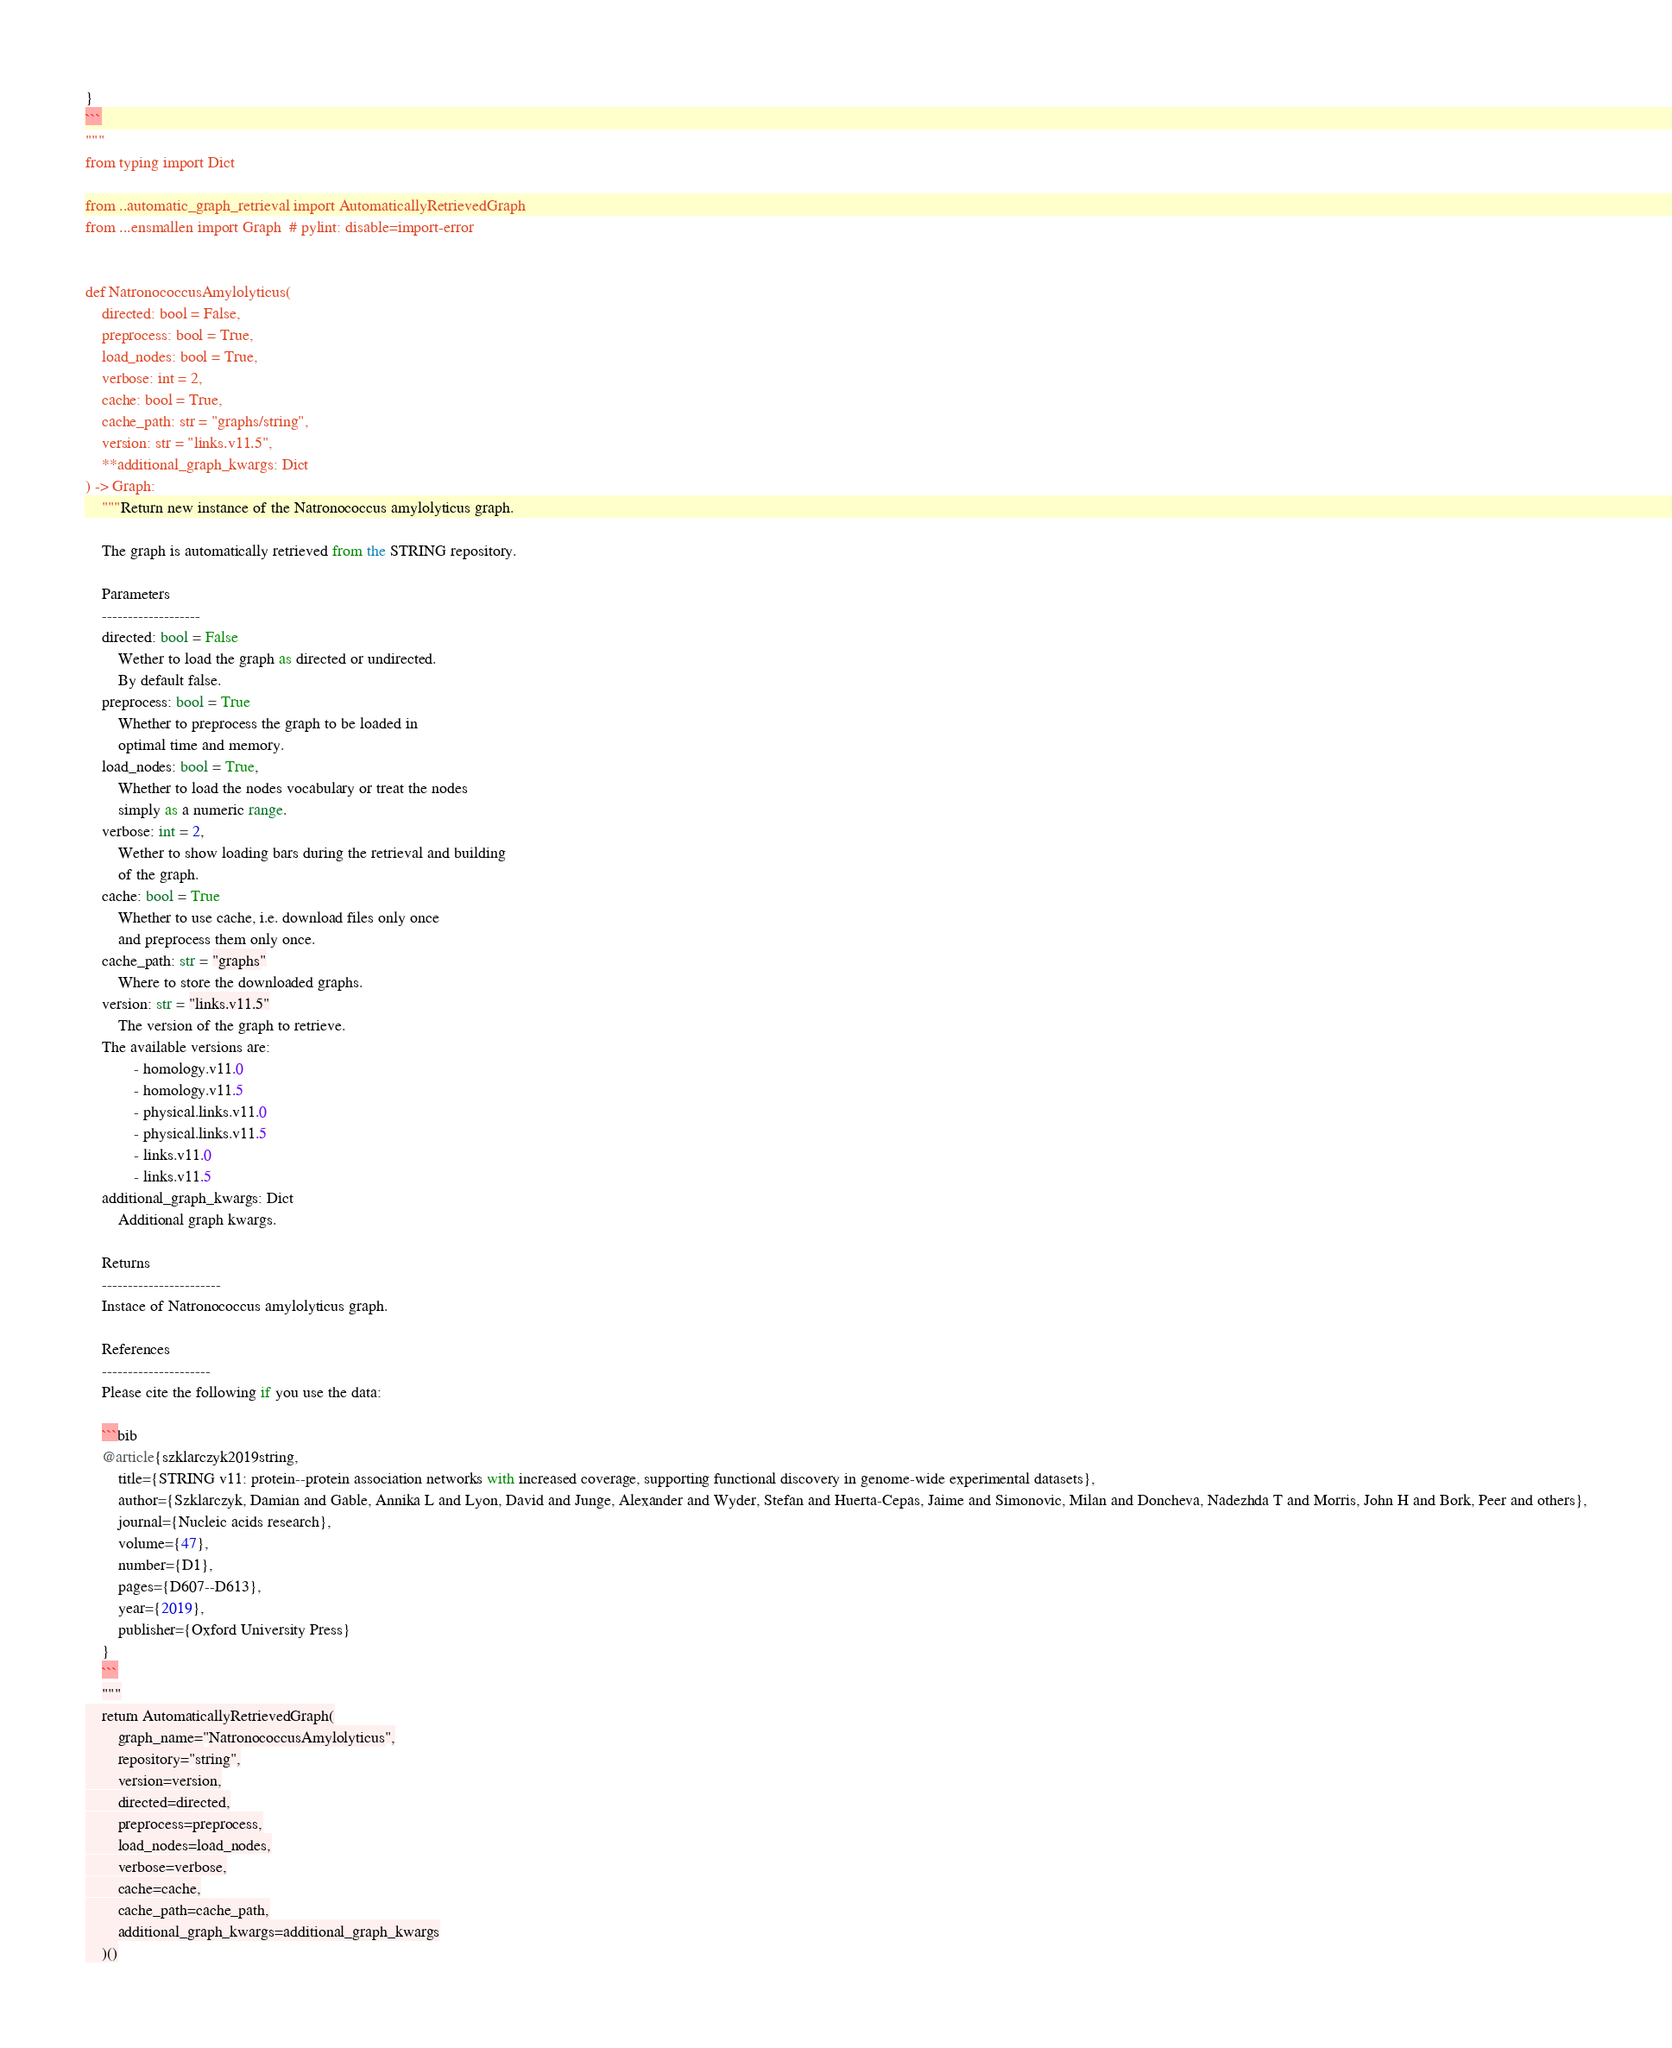Convert code to text. <code><loc_0><loc_0><loc_500><loc_500><_Python_>}
```
"""
from typing import Dict

from ..automatic_graph_retrieval import AutomaticallyRetrievedGraph
from ...ensmallen import Graph  # pylint: disable=import-error


def NatronococcusAmylolyticus(
    directed: bool = False,
    preprocess: bool = True,
    load_nodes: bool = True,
    verbose: int = 2,
    cache: bool = True,
    cache_path: str = "graphs/string",
    version: str = "links.v11.5",
    **additional_graph_kwargs: Dict
) -> Graph:
    """Return new instance of the Natronococcus amylolyticus graph.

    The graph is automatically retrieved from the STRING repository.	

    Parameters
    -------------------
    directed: bool = False
        Wether to load the graph as directed or undirected.
        By default false.
    preprocess: bool = True
        Whether to preprocess the graph to be loaded in 
        optimal time and memory.
    load_nodes: bool = True,
        Whether to load the nodes vocabulary or treat the nodes
        simply as a numeric range.
    verbose: int = 2,
        Wether to show loading bars during the retrieval and building
        of the graph.
    cache: bool = True
        Whether to use cache, i.e. download files only once
        and preprocess them only once.
    cache_path: str = "graphs"
        Where to store the downloaded graphs.
    version: str = "links.v11.5"
        The version of the graph to retrieve.		
	The available versions are:
			- homology.v11.0
			- homology.v11.5
			- physical.links.v11.0
			- physical.links.v11.5
			- links.v11.0
			- links.v11.5
    additional_graph_kwargs: Dict
        Additional graph kwargs.

    Returns
    -----------------------
    Instace of Natronococcus amylolyticus graph.

	References
	---------------------
	Please cite the following if you use the data:
	
	```bib
	@article{szklarczyk2019string,
	    title={STRING v11: protein--protein association networks with increased coverage, supporting functional discovery in genome-wide experimental datasets},
	    author={Szklarczyk, Damian and Gable, Annika L and Lyon, David and Junge, Alexander and Wyder, Stefan and Huerta-Cepas, Jaime and Simonovic, Milan and Doncheva, Nadezhda T and Morris, John H and Bork, Peer and others},
	    journal={Nucleic acids research},
	    volume={47},
	    number={D1},
	    pages={D607--D613},
	    year={2019},
	    publisher={Oxford University Press}
	}
	```
    """
    return AutomaticallyRetrievedGraph(
        graph_name="NatronococcusAmylolyticus",
        repository="string",
        version=version,
        directed=directed,
        preprocess=preprocess,
        load_nodes=load_nodes,
        verbose=verbose,
        cache=cache,
        cache_path=cache_path,
        additional_graph_kwargs=additional_graph_kwargs
    )()
</code> 